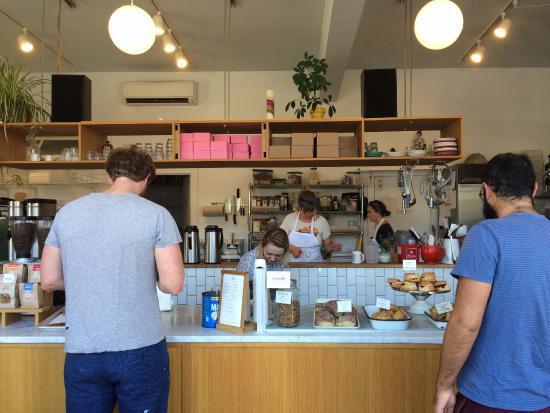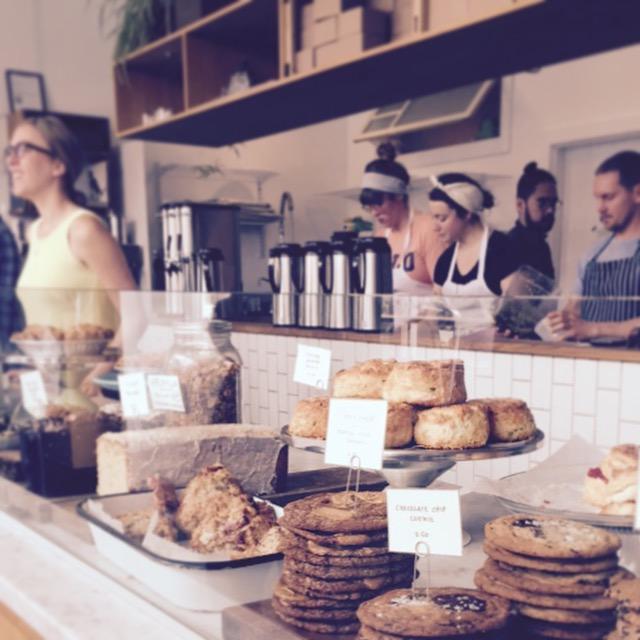The first image is the image on the left, the second image is the image on the right. For the images shown, is this caption "An image shows two people standing upright a distance apart in front of a counter with a light wood front and a top filled with containers of baked treats marked with cards." true? Answer yes or no. Yes. 